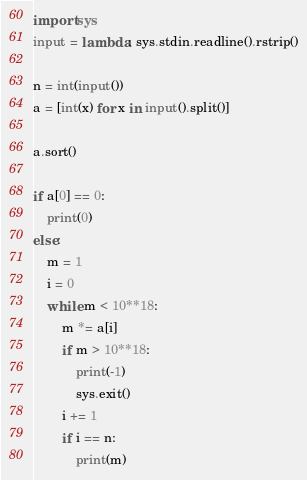<code> <loc_0><loc_0><loc_500><loc_500><_Python_>import sys
input = lambda: sys.stdin.readline().rstrip()

n = int(input())
a = [int(x) for x in input().split()]

a.sort()

if a[0] == 0:
    print(0)
else:
    m = 1
    i = 0
    while m < 10**18:
        m *= a[i]
        if m > 10**18:
            print(-1)
            sys.exit()
        i += 1
        if i == n:
            print(m)</code> 